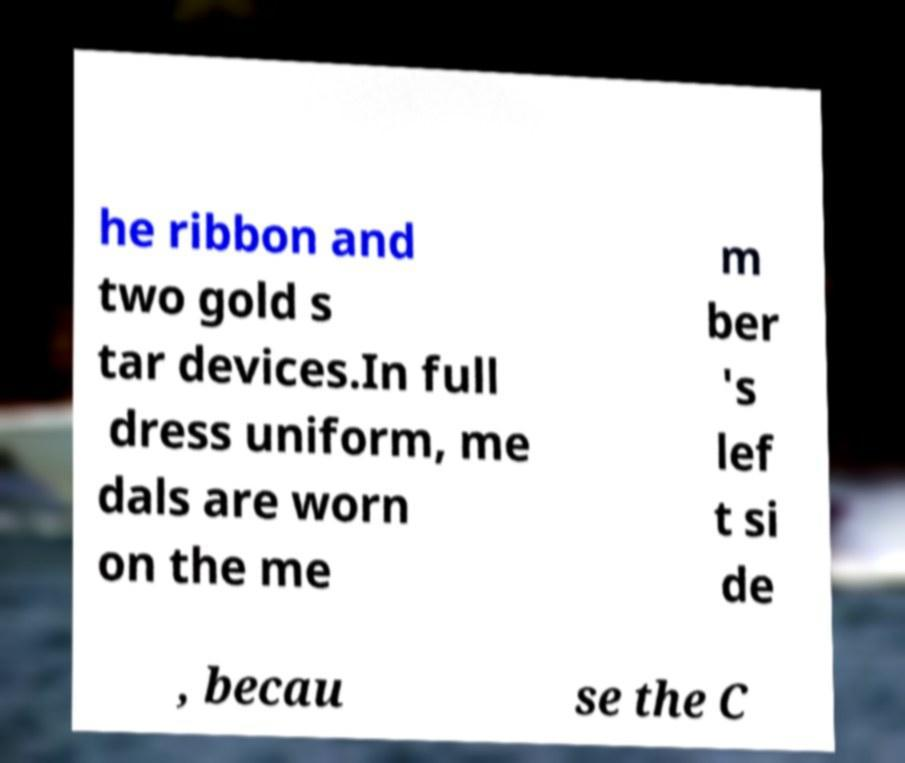There's text embedded in this image that I need extracted. Can you transcribe it verbatim? he ribbon and two gold s tar devices.In full dress uniform, me dals are worn on the me m ber 's lef t si de , becau se the C 